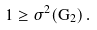Convert formula to latex. <formula><loc_0><loc_0><loc_500><loc_500>1 \geq \sigma ^ { 2 } ( G _ { 2 } ) \, .</formula> 